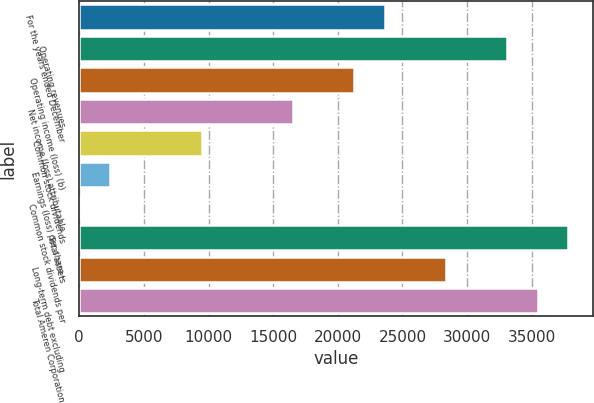<chart> <loc_0><loc_0><loc_500><loc_500><bar_chart><fcel>For the years ended December<fcel>Operating revenues<fcel>Operating income (loss) (b)<fcel>Net income (loss) attributable<fcel>Common stock dividends<fcel>Earnings (loss) per share -<fcel>Common stock dividends per<fcel>Total assets<fcel>Long-term debt excluding<fcel>Total Ameren Corporation<nl><fcel>23645<fcel>33102.4<fcel>21280.7<fcel>16552<fcel>9458.94<fcel>2365.9<fcel>1.55<fcel>37831.1<fcel>28373.7<fcel>35466.7<nl></chart> 